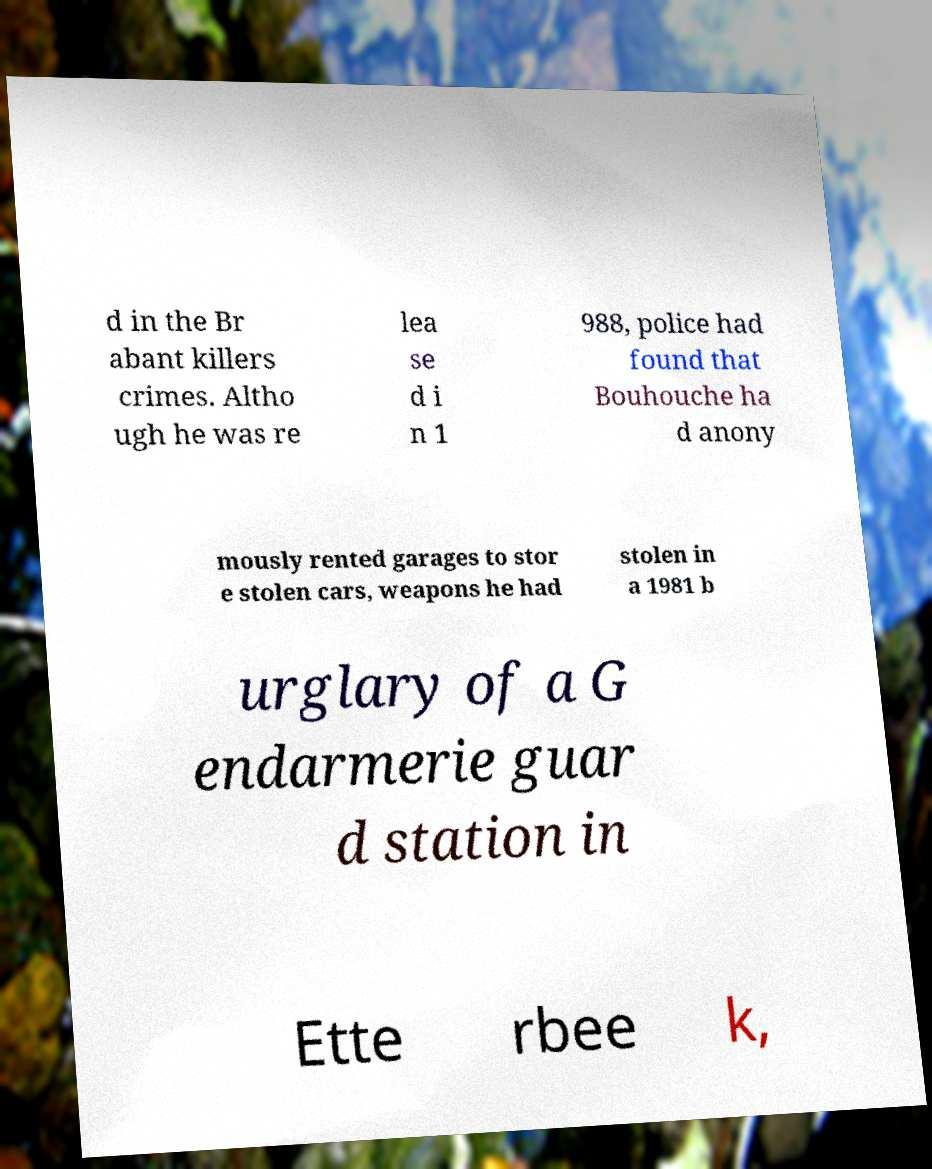Please read and relay the text visible in this image. What does it say? d in the Br abant killers crimes. Altho ugh he was re lea se d i n 1 988, police had found that Bouhouche ha d anony mously rented garages to stor e stolen cars, weapons he had stolen in a 1981 b urglary of a G endarmerie guar d station in Ette rbee k, 